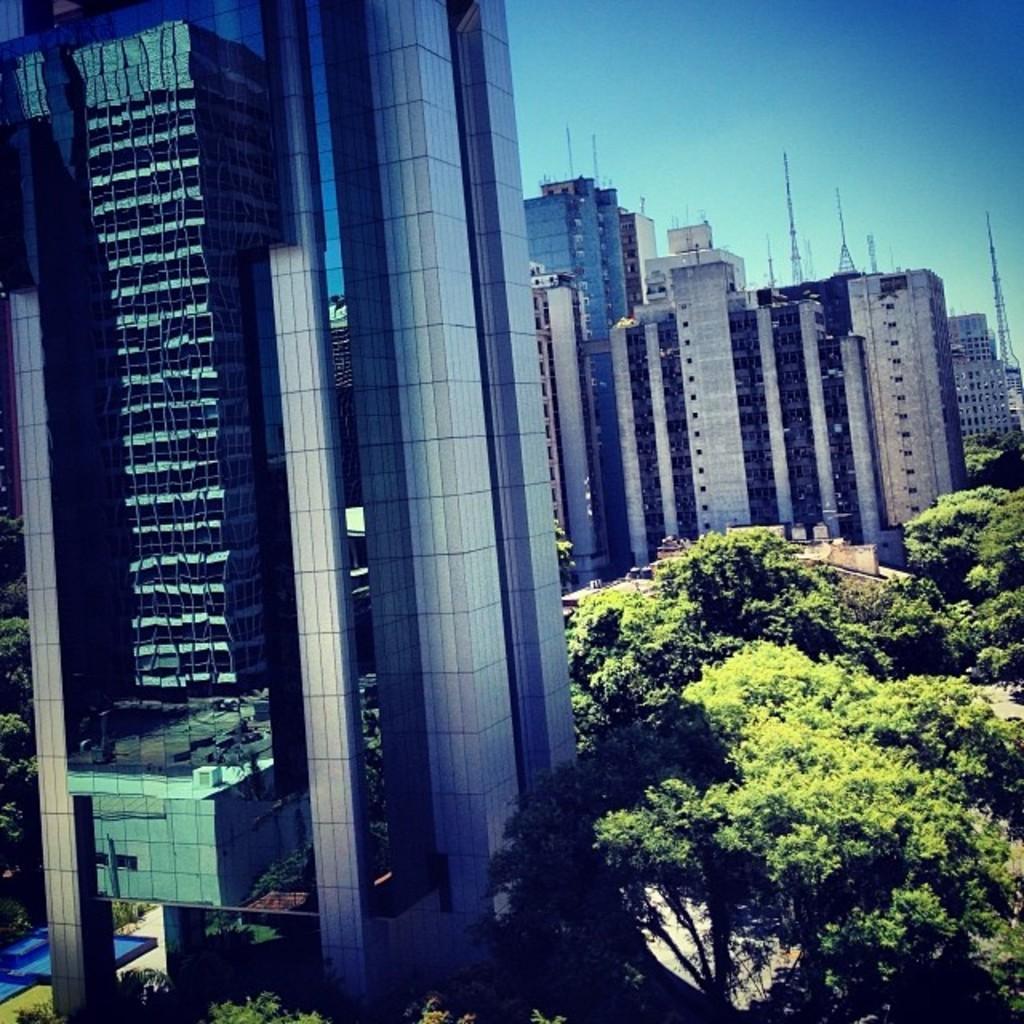Could you give a brief overview of what you see in this image? In this image I see number of buildings and I see number of trees. In the background I see the sky and I see few towers. 